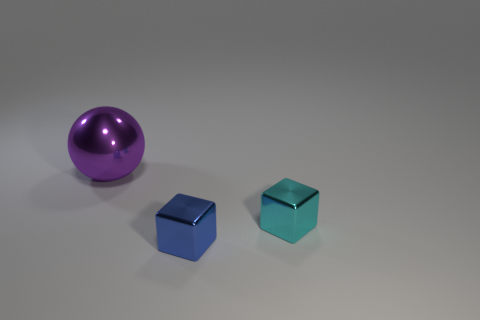Could you describe the lighting and shadows in the scene? Certainly. The scene is lit in a way that creates soft shadows directly beneath the objects, suggesting a diffuse light source located above and slightly to the front of them. The way the shadows fade smoothly indicates that the light is not harsh, and this diffuse lighting helps to highlight the reflective and translucent qualities of the objects without creating overly sharp or distracting reflections. 